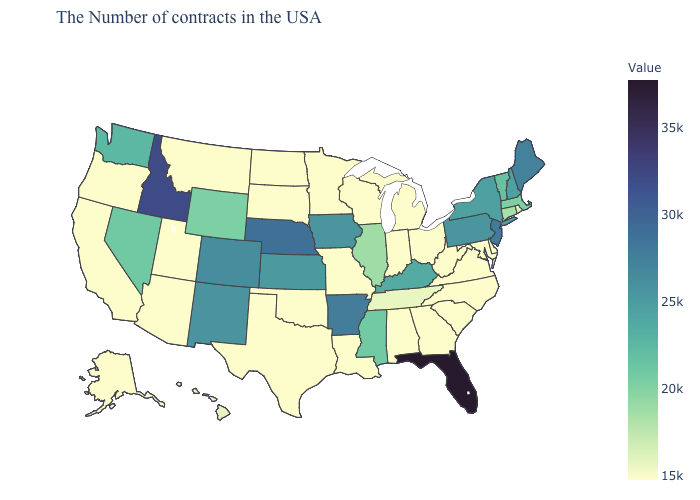Among the states that border New Mexico , does Utah have the highest value?
Write a very short answer. No. Does Oklahoma have the highest value in the South?
Give a very brief answer. No. Is the legend a continuous bar?
Be succinct. Yes. Which states hav the highest value in the Northeast?
Keep it brief. New Jersey. Does Virginia have the highest value in the USA?
Short answer required. No. Does South Carolina have the lowest value in the USA?
Answer briefly. Yes. Which states have the highest value in the USA?
Write a very short answer. Florida. 